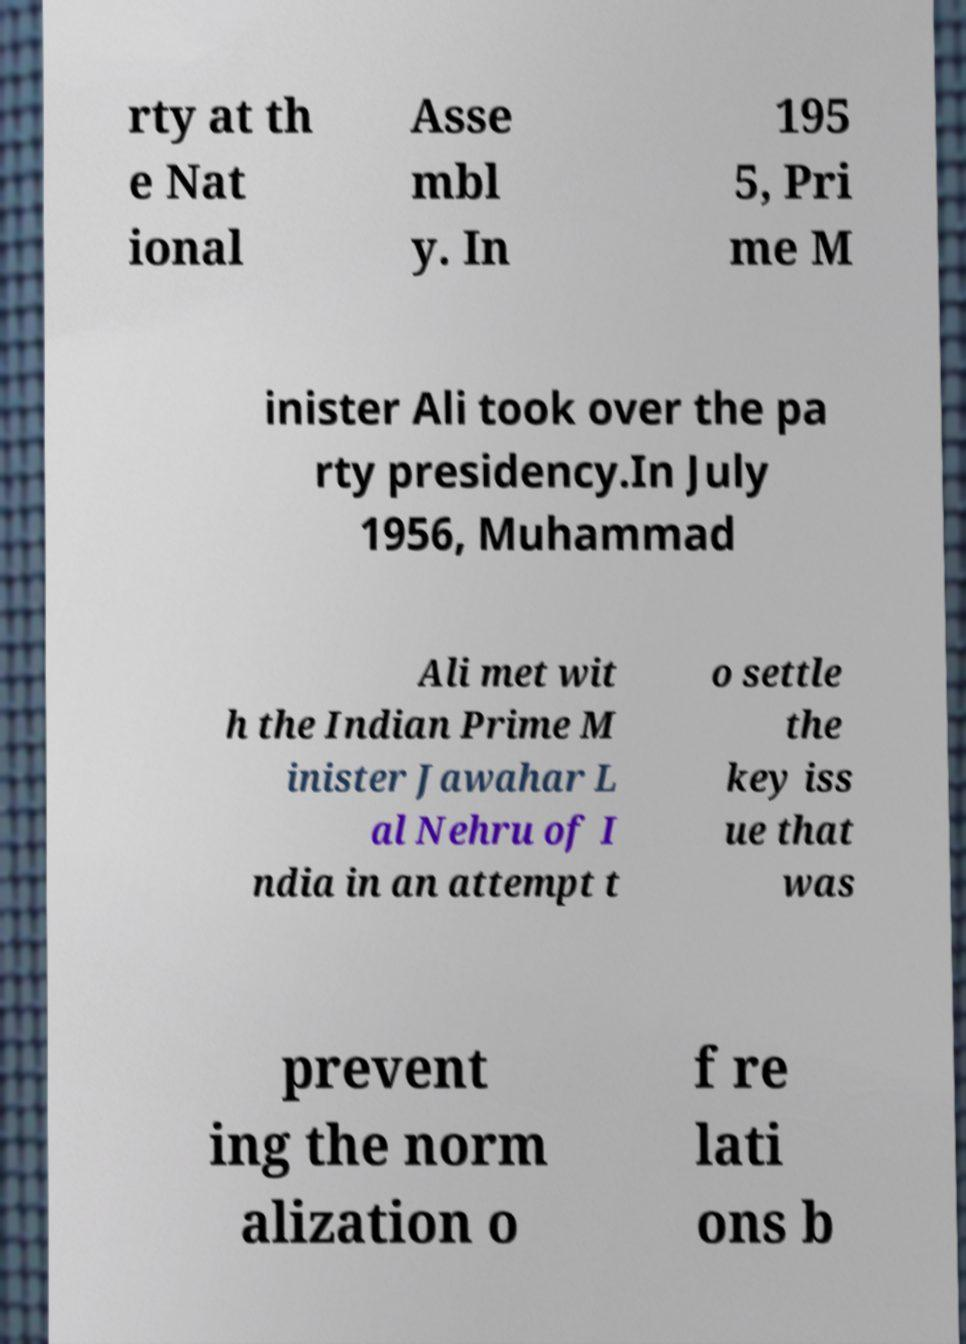There's text embedded in this image that I need extracted. Can you transcribe it verbatim? rty at th e Nat ional Asse mbl y. In 195 5, Pri me M inister Ali took over the pa rty presidency.In July 1956, Muhammad Ali met wit h the Indian Prime M inister Jawahar L al Nehru of I ndia in an attempt t o settle the key iss ue that was prevent ing the norm alization o f re lati ons b 